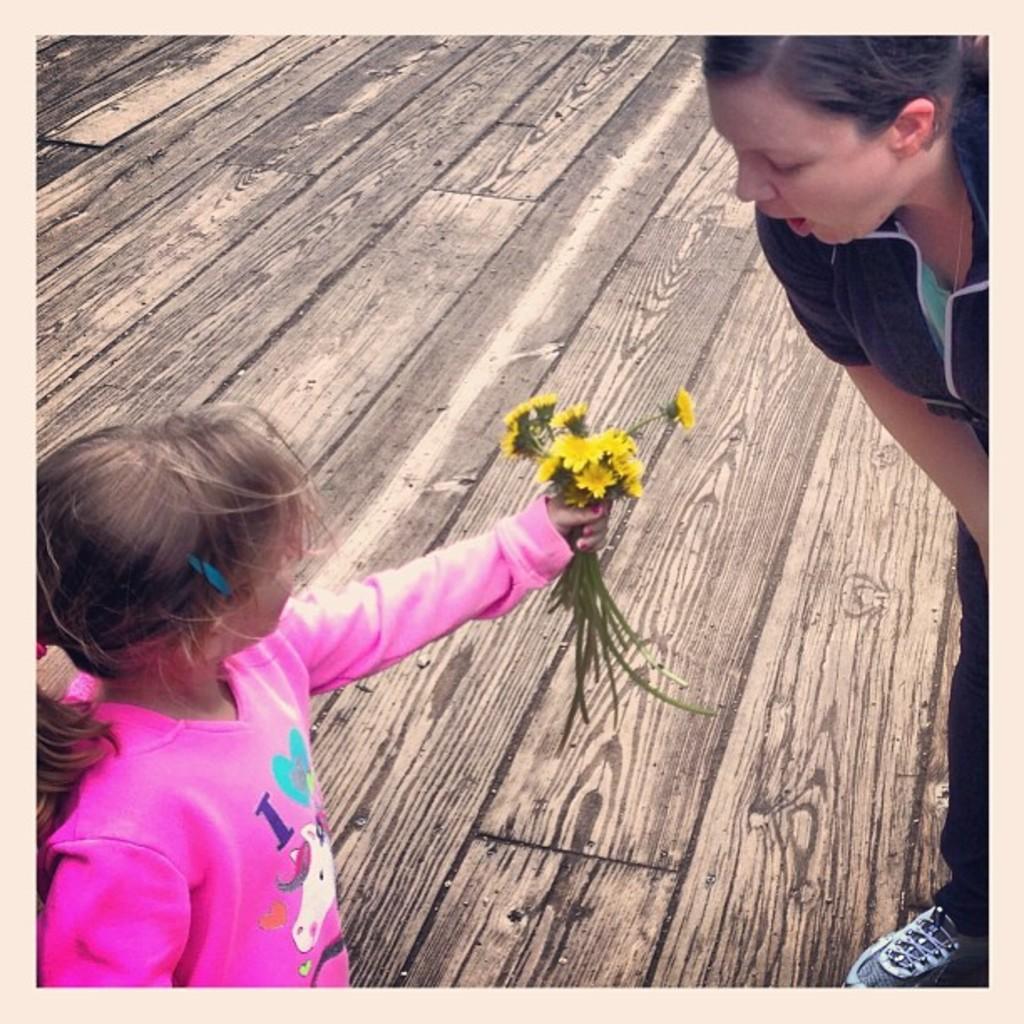How would you summarize this image in a sentence or two? In this image there is a girl standing on the wooden floor by holding the flowers. In front of her there is a woman who is standing on the floor. At the bottom there is a wooden floor. 